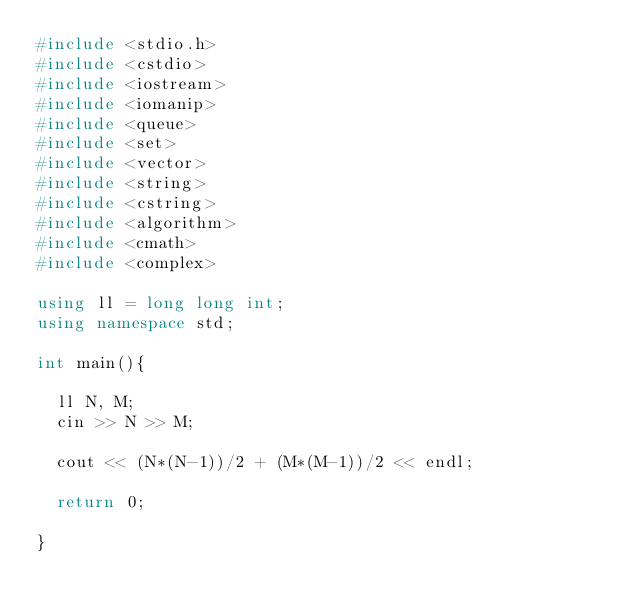Convert code to text. <code><loc_0><loc_0><loc_500><loc_500><_C++_>#include <stdio.h>
#include <cstdio>
#include <iostream>
#include <iomanip>
#include <queue>
#include <set>
#include <vector>
#include <string>
#include <cstring>
#include <algorithm>
#include <cmath>
#include <complex>

using ll = long long int;
using namespace std;

int main(){

  ll N, M;
  cin >> N >> M;

  cout << (N*(N-1))/2 + (M*(M-1))/2 << endl;

  return 0;
  
}
</code> 